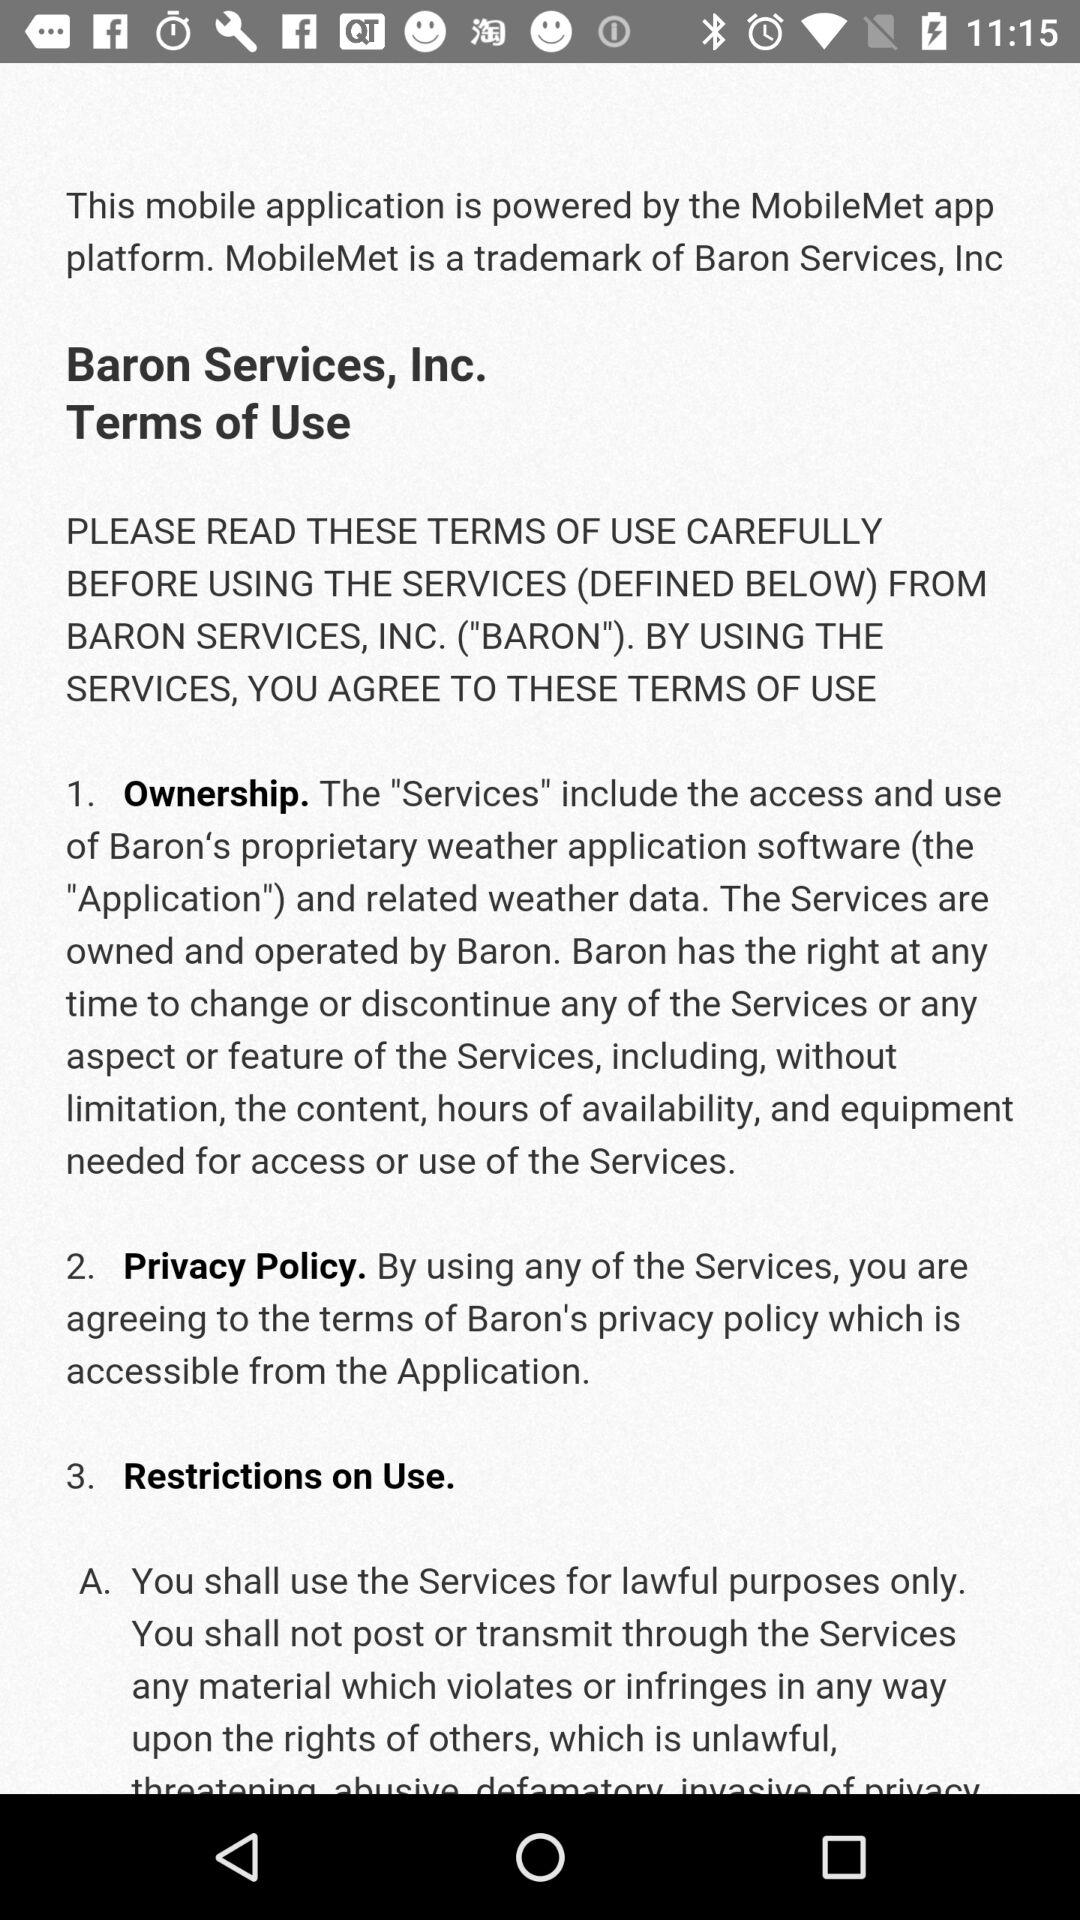What are the terms of use? The terms of use are "Ownership", "Privacy Policy" and "Restrictions on Use". 